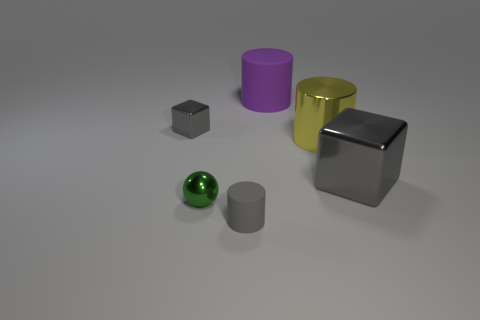Add 2 green objects. How many objects exist? 8 Subtract all balls. How many objects are left? 5 Add 5 purple cylinders. How many purple cylinders are left? 6 Add 1 tiny gray cylinders. How many tiny gray cylinders exist? 2 Subtract 0 cyan blocks. How many objects are left? 6 Subtract all balls. Subtract all large cylinders. How many objects are left? 3 